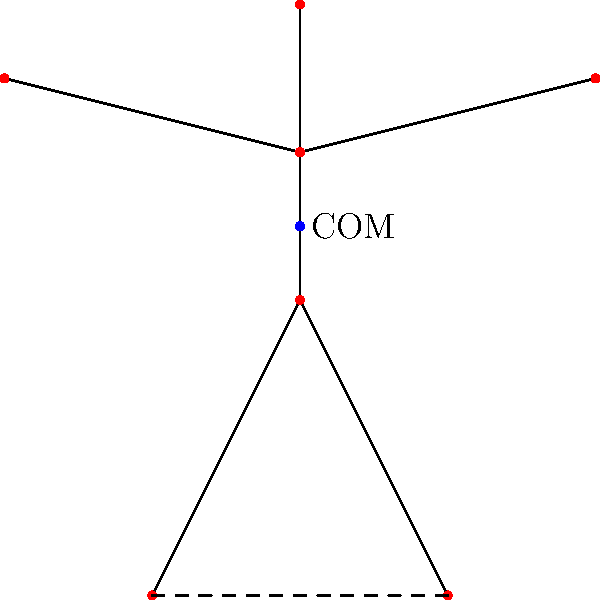As a TV show producer casting for an acrobatic performance, you need to understand the biomechanics of balance. In the figure, an acrobat is shown in a challenging pose. If the acrobat's center of mass (COM) is directly above the midpoint between their feet, what would be the primary factor affecting their stability? To understand the stability of the acrobat, we need to consider the following factors:

1. Center of Mass (COM): The COM is the average position of all the mass in the body. In this case, it's shown as a blue dot above the midpoint of the feet.

2. Base of Support (BOS): This is the area between the points of contact with the ground. Here, it's the line between the acrobat's feet.

3. Projection of COM: The vertical projection of the COM falls within the BOS, which is crucial for static balance.

4. Height of COM: The COM is relatively high above the BOS.

5. Width of BOS: The distance between the feet determines the width of the BOS.

Given that the COM is directly above the midpoint of the feet, the acrobat has achieved static balance. However, the primary factor affecting stability in this pose would be the height of the COM relative to the BOS.

A higher COM increases the potential energy of the system, making it more susceptible to perturbations. Any small movement or external force could more easily move the projection of the COM outside the BOS, causing instability.

The width of the BOS is also important, but since the COM is centered, widening the stance would equally improve stability in all directions. The height of the COM, however, directly impacts the amount of torque generated by any perturbation, making it the primary factor affecting stability in this pose.
Answer: Height of the center of mass above the base of support 